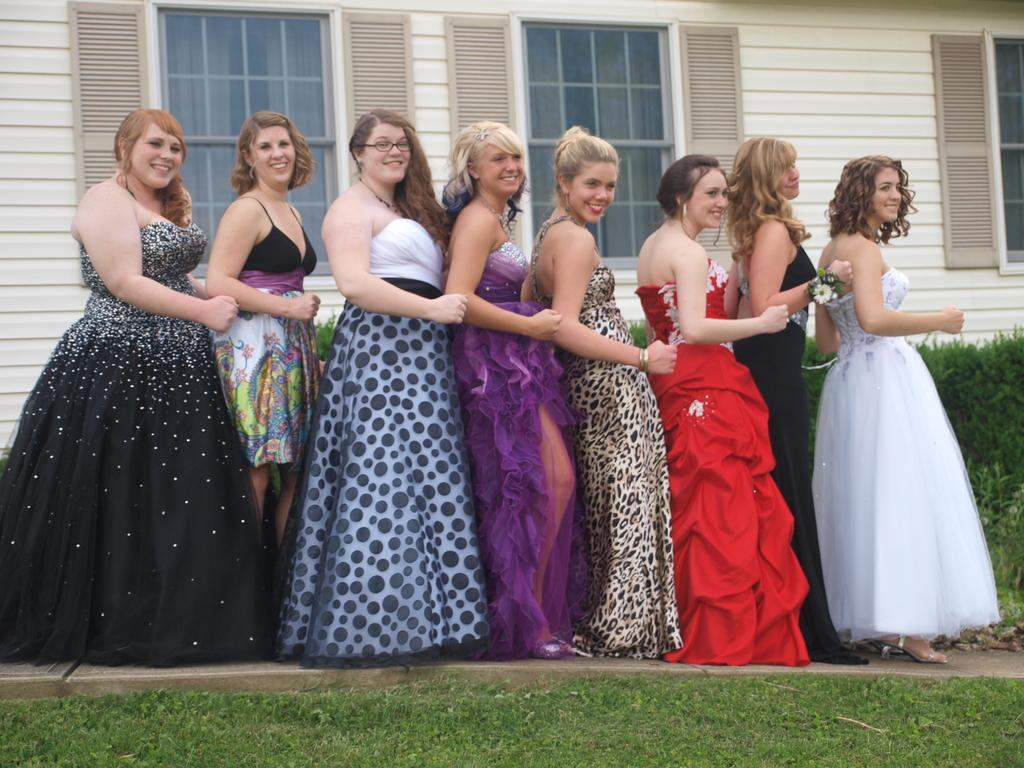What is happening in the image? There are people standing in the image. How can you describe the clothing of the people? The people are wearing different color dresses. What type of structure is present in the image? There is a building in the image. What architectural feature can be seen on the building? There are windows visible in the image. What type of vegetation is present in the image? There are plants in the image. What type of vest can be seen on the plants in the image? There are no vests present on the plants in the image. How does the twig contribute to the people's desire in the image? There is no twig or mention of desire in the image. 